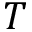<formula> <loc_0><loc_0><loc_500><loc_500>T</formula> 